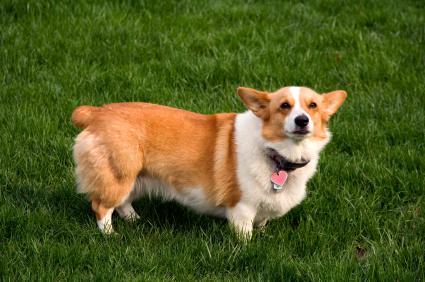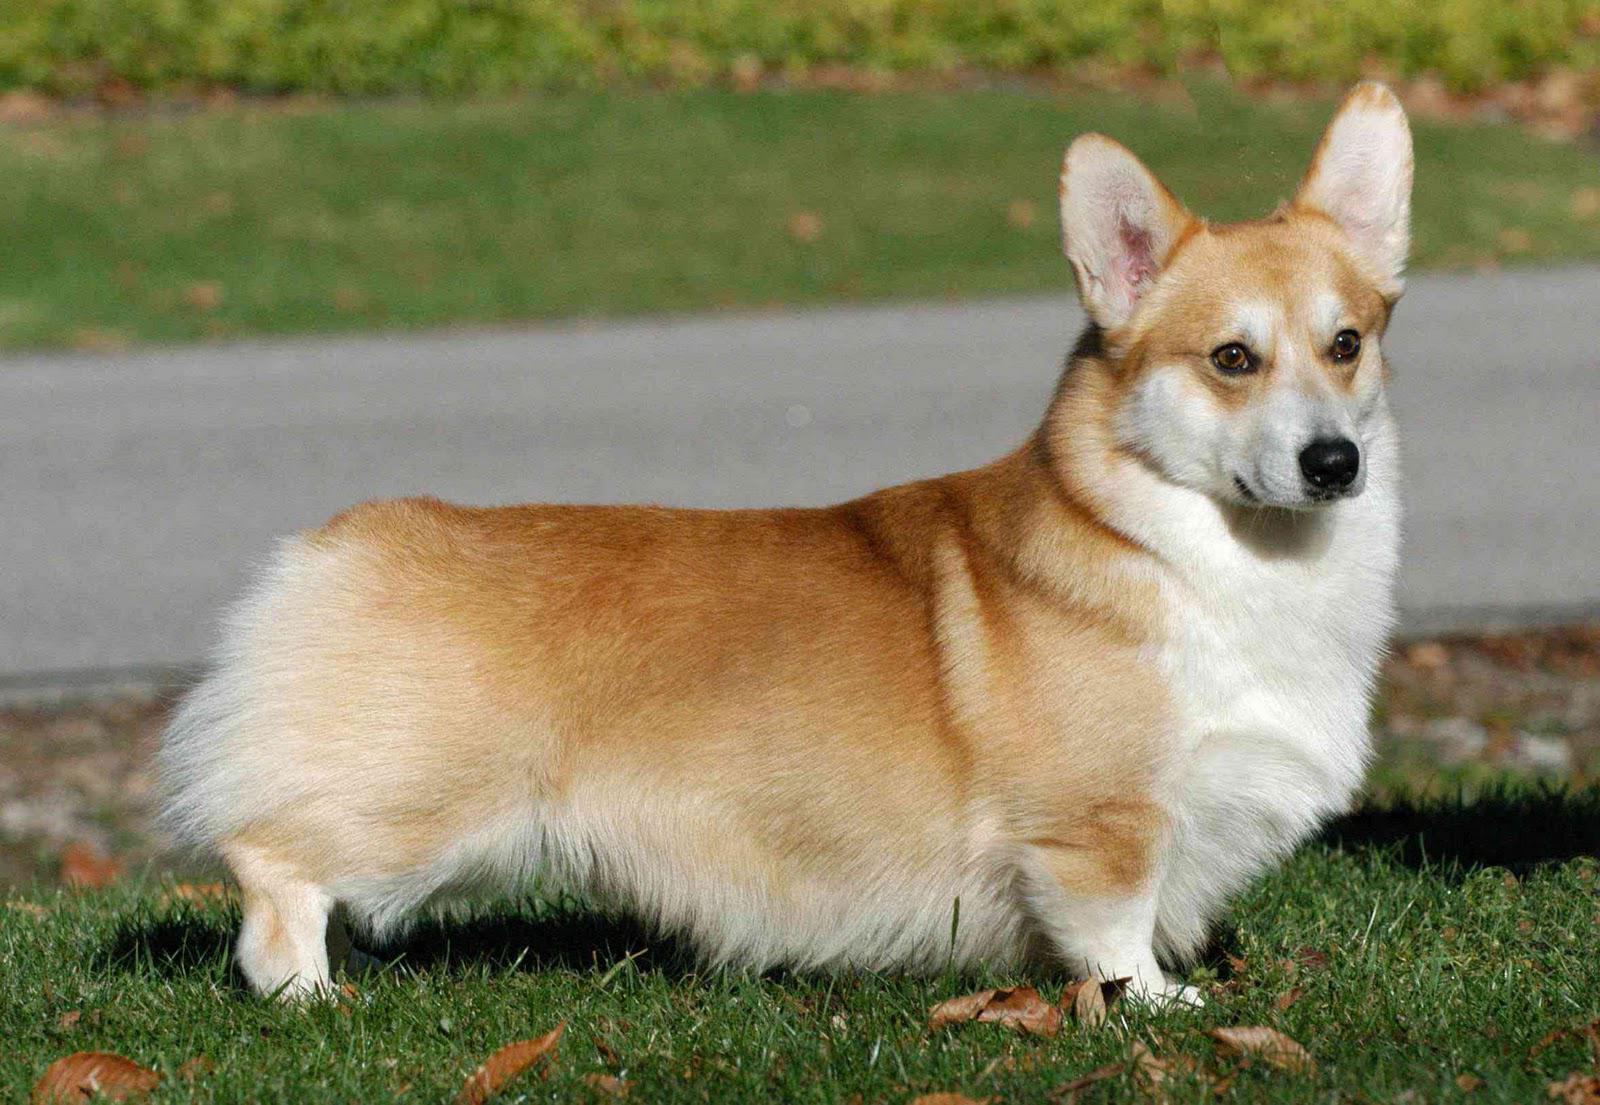The first image is the image on the left, the second image is the image on the right. Evaluate the accuracy of this statement regarding the images: "The bodies of both dogs are facing the right.". Is it true? Answer yes or no. Yes. 